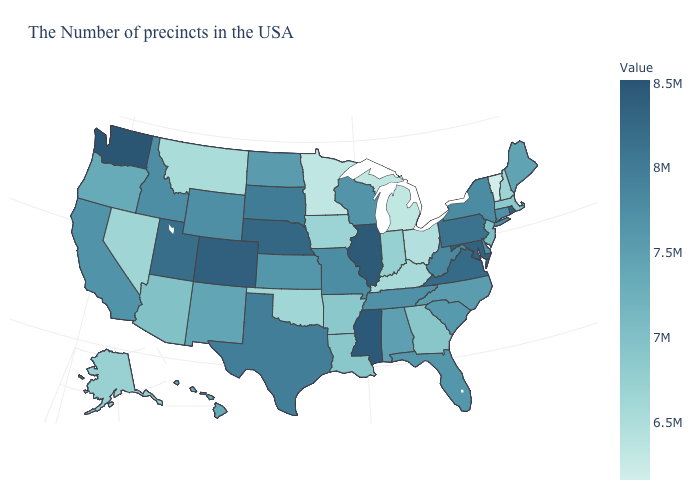Does Illinois have the highest value in the MidWest?
Be succinct. Yes. Among the states that border Tennessee , which have the lowest value?
Quick response, please. Kentucky. Does Louisiana have the lowest value in the USA?
Write a very short answer. No. Does Vermont have the lowest value in the Northeast?
Concise answer only. Yes. 